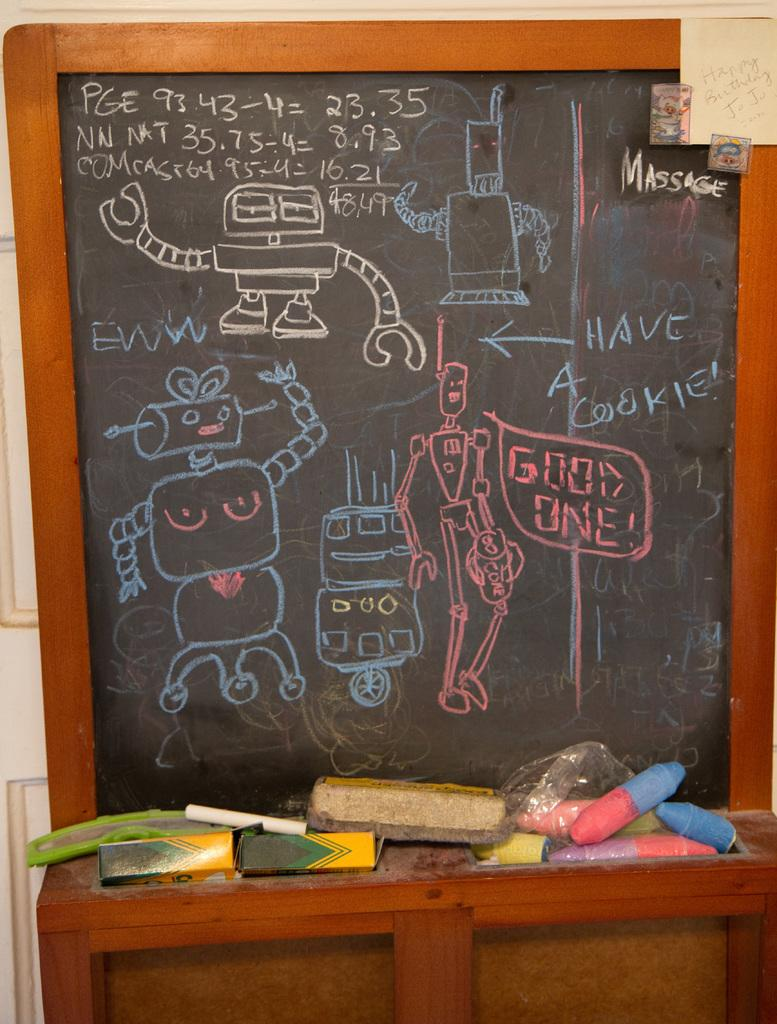<image>
Relay a brief, clear account of the picture shown. A pink robot saying"Good One" drawn on chalkboard with other colorful robots. 